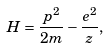<formula> <loc_0><loc_0><loc_500><loc_500>H = \frac { p ^ { 2 } } { 2 m } - \frac { e ^ { 2 } } { z } ,</formula> 